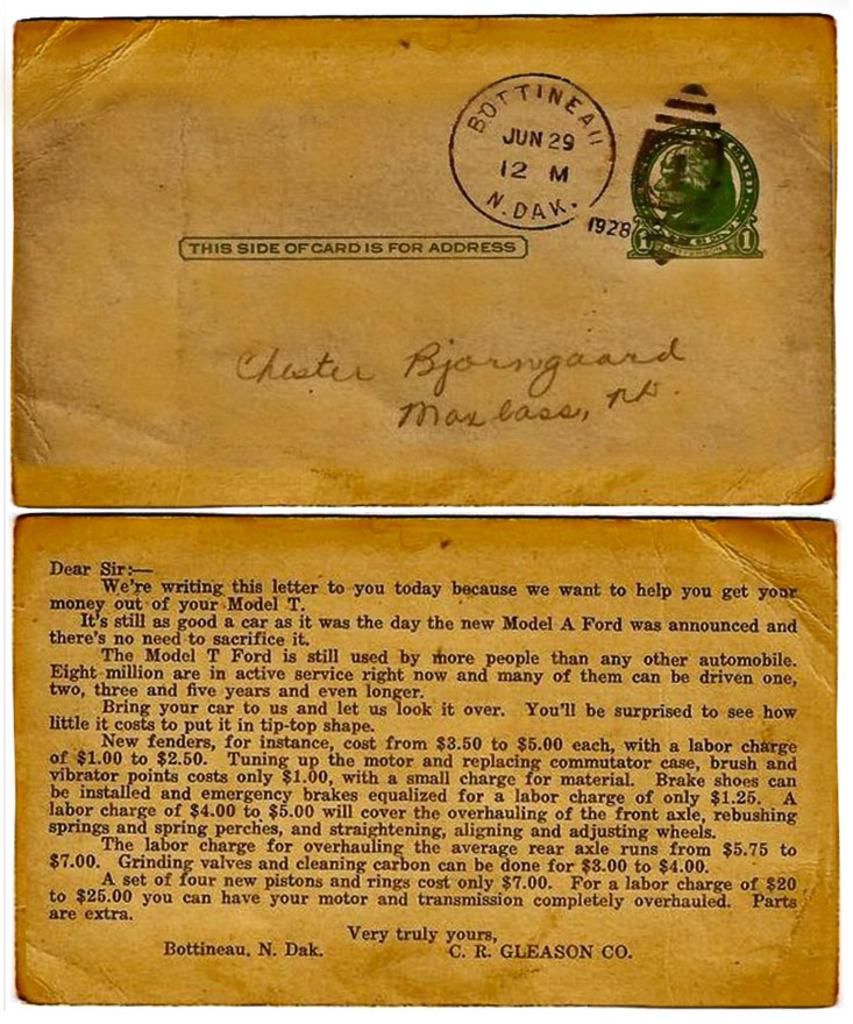<image>
Summarize the visual content of the image. a very old telegram or letter addressed to Chester Bjornguard. 